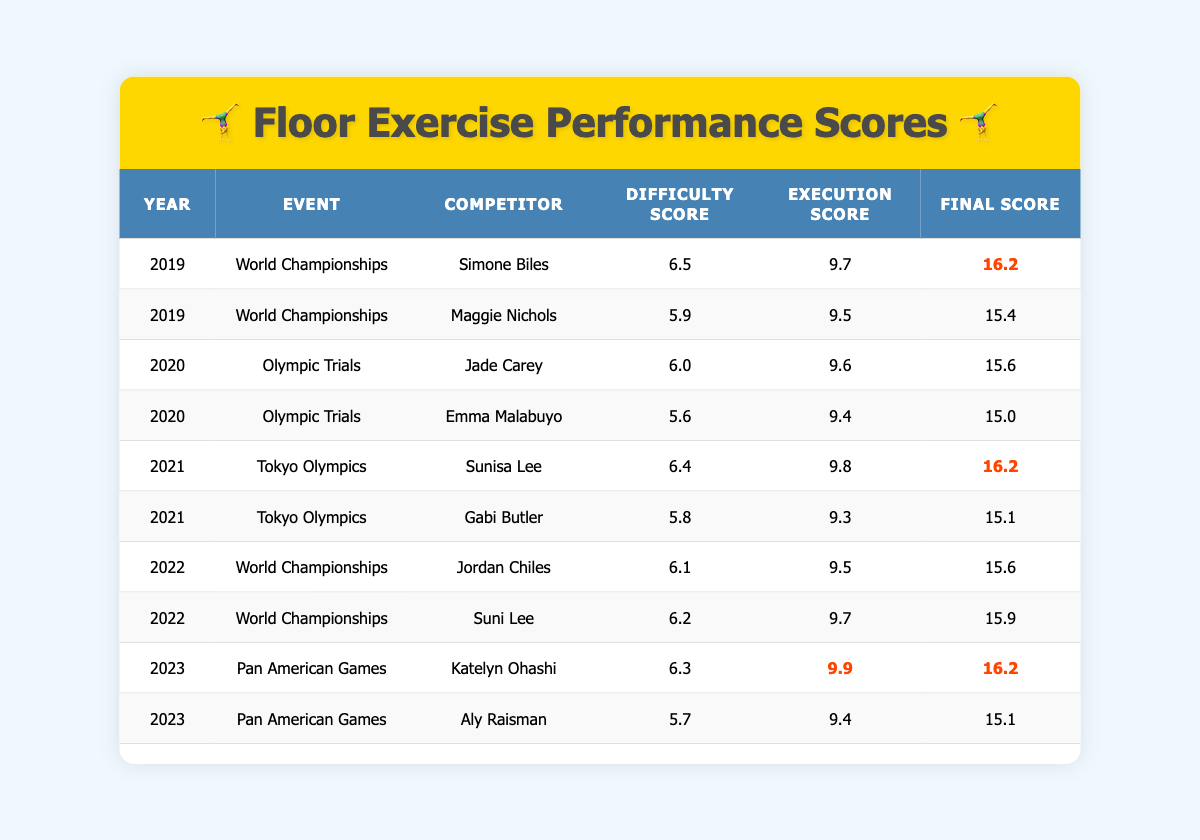What was the highest Final Score in 2021? In 2021, the two competitors were Sunisa Lee (Final Score: 16.2) and Gabi Butler (Final Score: 15.1). Comparing these scores, Sunisa Lee has the highest score of 16.2.
Answer: 16.2 Who had the highest Execution Score in 2023? In 2023, Katelyn Ohashi had an Execution Score of 9.9, while Aly Raisman had an Execution Score of 9.4. Therefore, Katelyn Ohashi had the highest Execution Score in 2023.
Answer: 9.9 What is the average Difficulty Score from the 2019 World Championships? The Difficulty Scores for the 2019 World Championships are 6.5 (Simone Biles) and 5.9 (Maggie Nichols). Adding these scores gives 6.5 + 5.9 = 12.4. Dividing by 2 gives an average of 12.4/2 = 6.2.
Answer: 6.2 Did anyone score a Final Score above 16 in the 2020 Olympic Trials? The Final Scores from the 2020 Olympic Trials are 15.6 (Jade Carey) and 15.0 (Emma Malabuyo). Both scores are below 16, so no one scored above 16.
Answer: No Which year had the most competitors listed in the table? Looking at the data by year: 2019 has 2 competitors, 2020 has 2 competitors, 2021 has 2 competitors, 2022 has 2 competitors, and 2023 has 2 competitors. All years have the same number of competitors, 2.
Answer: None What was the difference in Final Scores between the competitors in the 2021 Tokyo Olympics? The Final Scores for Sunisa Lee is 16.2 and for Gabi Butler is 15.1. The difference is calculated as 16.2 - 15.1 = 1.1.
Answer: 1.1 Which competitor had the highest Difficulty Score across all events listed? After comparing all Difficulty Scores: Simone Biles (6.5), Jade Carey (6.0), Sunisa Lee (6.4), Jordan Chiles (6.1), Katelyn Ohashi (6.3), and others, Simone Biles has the highest Difficulty Score of 6.5.
Answer: 6.5 Was the average Final Score for competitors in the 2022 World Championships greater than 15.5? The Final Scores for the 2022 World Championships are 15.6 (Jordan Chiles) and 15.9 (Suni Lee). The average is (15.6 + 15.9) / 2 = 15.75, which is greater than 15.5.
Answer: Yes How many competitors had a Final Score of 15.6 in 2022? In 2022, Jordan Chiles scored 15.6, but no other competitor's score matches this. Therefore, there is only one competitor with a Final Score of 15.6 in 2022.
Answer: 1 What year had the lowest average Execution Score among all competitors? Calculating the Execution Scores for each year: 2019: (9.7 + 9.5) / 2 = 9.6; 2020: (9.6 + 9.4) / 2 = 9.5; 2021: (9.8 + 9.3) / 2 = 9.55; 2022: (9.5 + 9.7) / 2 = 9.6; 2023: (9.9 + 9.4) / 2 = 9.65. The lowest average is for 2020 with 9.5.
Answer: 2020 